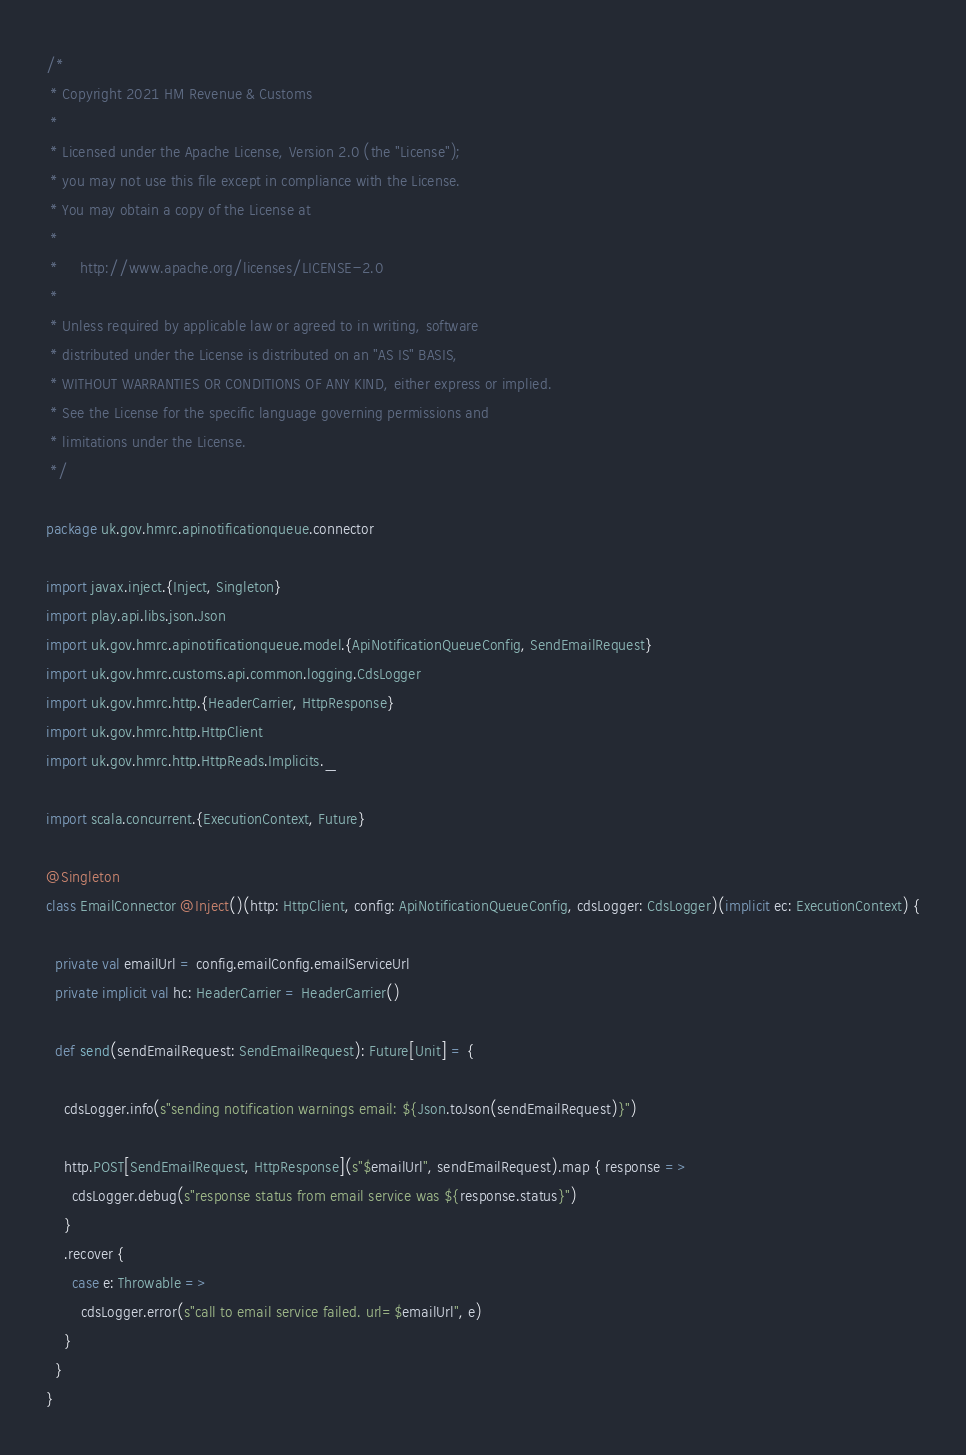Convert code to text. <code><loc_0><loc_0><loc_500><loc_500><_Scala_>/*
 * Copyright 2021 HM Revenue & Customs
 *
 * Licensed under the Apache License, Version 2.0 (the "License");
 * you may not use this file except in compliance with the License.
 * You may obtain a copy of the License at
 *
 *     http://www.apache.org/licenses/LICENSE-2.0
 *
 * Unless required by applicable law or agreed to in writing, software
 * distributed under the License is distributed on an "AS IS" BASIS,
 * WITHOUT WARRANTIES OR CONDITIONS OF ANY KIND, either express or implied.
 * See the License for the specific language governing permissions and
 * limitations under the License.
 */

package uk.gov.hmrc.apinotificationqueue.connector

import javax.inject.{Inject, Singleton}
import play.api.libs.json.Json
import uk.gov.hmrc.apinotificationqueue.model.{ApiNotificationQueueConfig, SendEmailRequest}
import uk.gov.hmrc.customs.api.common.logging.CdsLogger
import uk.gov.hmrc.http.{HeaderCarrier, HttpResponse}
import uk.gov.hmrc.http.HttpClient
import uk.gov.hmrc.http.HttpReads.Implicits._

import scala.concurrent.{ExecutionContext, Future}

@Singleton
class EmailConnector @Inject()(http: HttpClient, config: ApiNotificationQueueConfig, cdsLogger: CdsLogger)(implicit ec: ExecutionContext) {

  private val emailUrl = config.emailConfig.emailServiceUrl
  private implicit val hc: HeaderCarrier = HeaderCarrier()

  def send(sendEmailRequest: SendEmailRequest): Future[Unit] = {

    cdsLogger.info(s"sending notification warnings email: ${Json.toJson(sendEmailRequest)}")

    http.POST[SendEmailRequest, HttpResponse](s"$emailUrl", sendEmailRequest).map { response =>
      cdsLogger.debug(s"response status from email service was ${response.status}")
    }
    .recover {
      case e: Throwable =>
        cdsLogger.error(s"call to email service failed. url=$emailUrl", e)
    }
  }
}
</code> 